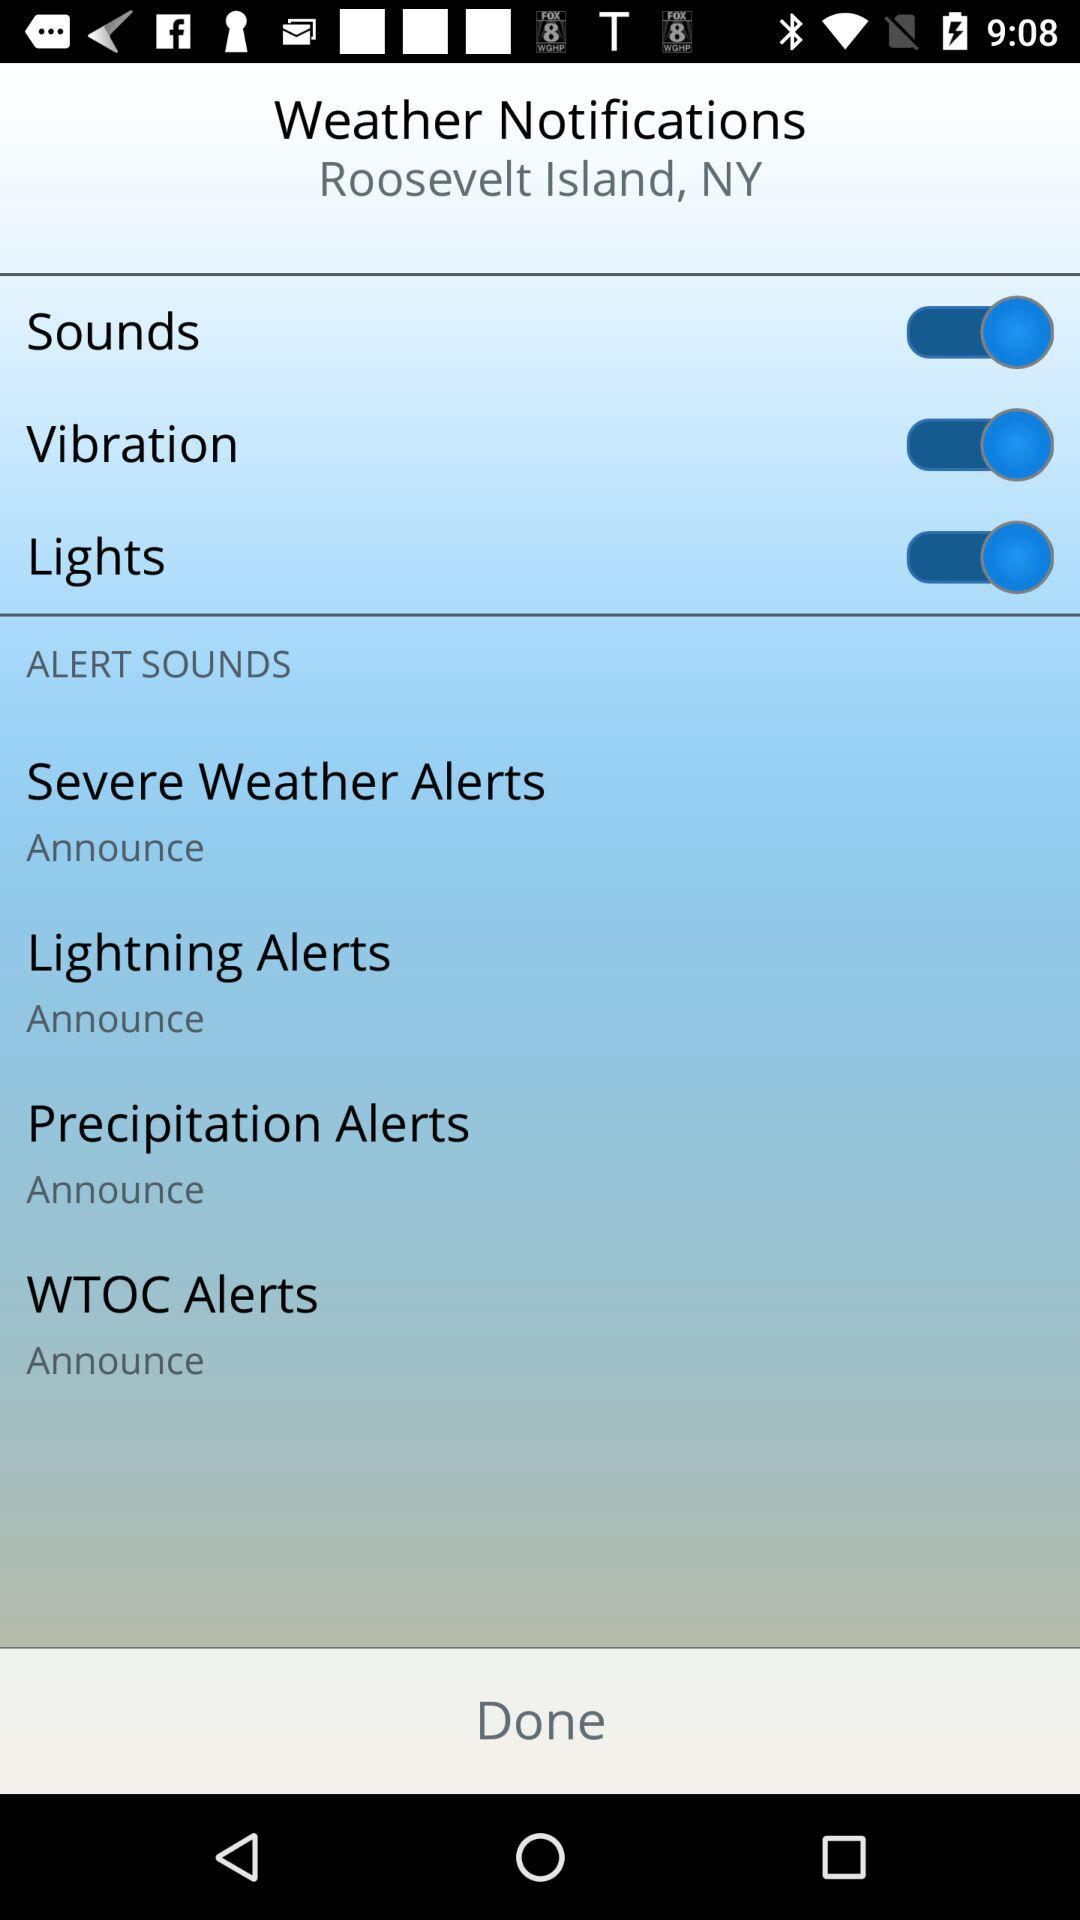What are the options that are enabled? The enabled options are "Sounds", "Vibration" and "Lights". 